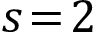<formula> <loc_0><loc_0><loc_500><loc_500>s \, = \, 2</formula> 